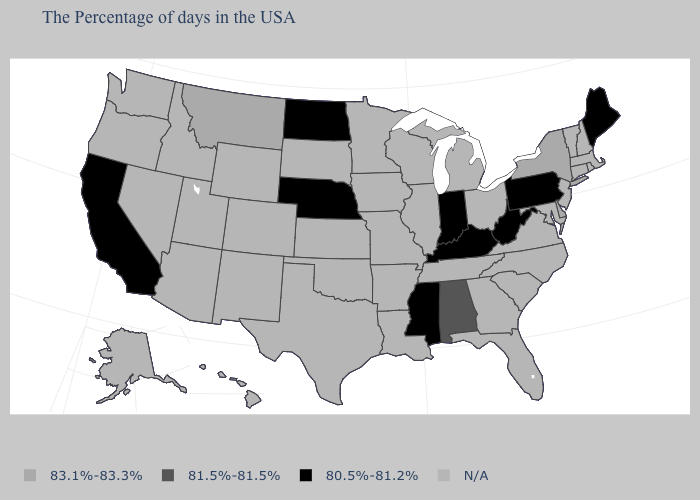Is the legend a continuous bar?
Write a very short answer. No. What is the value of Kansas?
Concise answer only. N/A. Name the states that have a value in the range 81.5%-81.5%?
Answer briefly. Alabama. What is the value of West Virginia?
Answer briefly. 80.5%-81.2%. Does the first symbol in the legend represent the smallest category?
Short answer required. No. Name the states that have a value in the range 81.5%-81.5%?
Quick response, please. Alabama. Name the states that have a value in the range 81.5%-81.5%?
Concise answer only. Alabama. Name the states that have a value in the range N/A?
Give a very brief answer. Massachusetts, Rhode Island, New Hampshire, Vermont, Connecticut, New Jersey, Maryland, Virginia, North Carolina, South Carolina, Ohio, Florida, Georgia, Michigan, Tennessee, Wisconsin, Illinois, Louisiana, Missouri, Arkansas, Minnesota, Iowa, Kansas, Oklahoma, Texas, South Dakota, Wyoming, Colorado, New Mexico, Utah, Arizona, Idaho, Nevada, Washington, Oregon, Alaska, Hawaii. Name the states that have a value in the range 80.5%-81.2%?
Write a very short answer. Maine, Pennsylvania, West Virginia, Kentucky, Indiana, Mississippi, Nebraska, North Dakota, California. What is the value of New Mexico?
Keep it brief. N/A. What is the highest value in the MidWest ?
Write a very short answer. 80.5%-81.2%. What is the value of Hawaii?
Short answer required. N/A. Name the states that have a value in the range 80.5%-81.2%?
Answer briefly. Maine, Pennsylvania, West Virginia, Kentucky, Indiana, Mississippi, Nebraska, North Dakota, California. Which states have the lowest value in the South?
Answer briefly. West Virginia, Kentucky, Mississippi. 